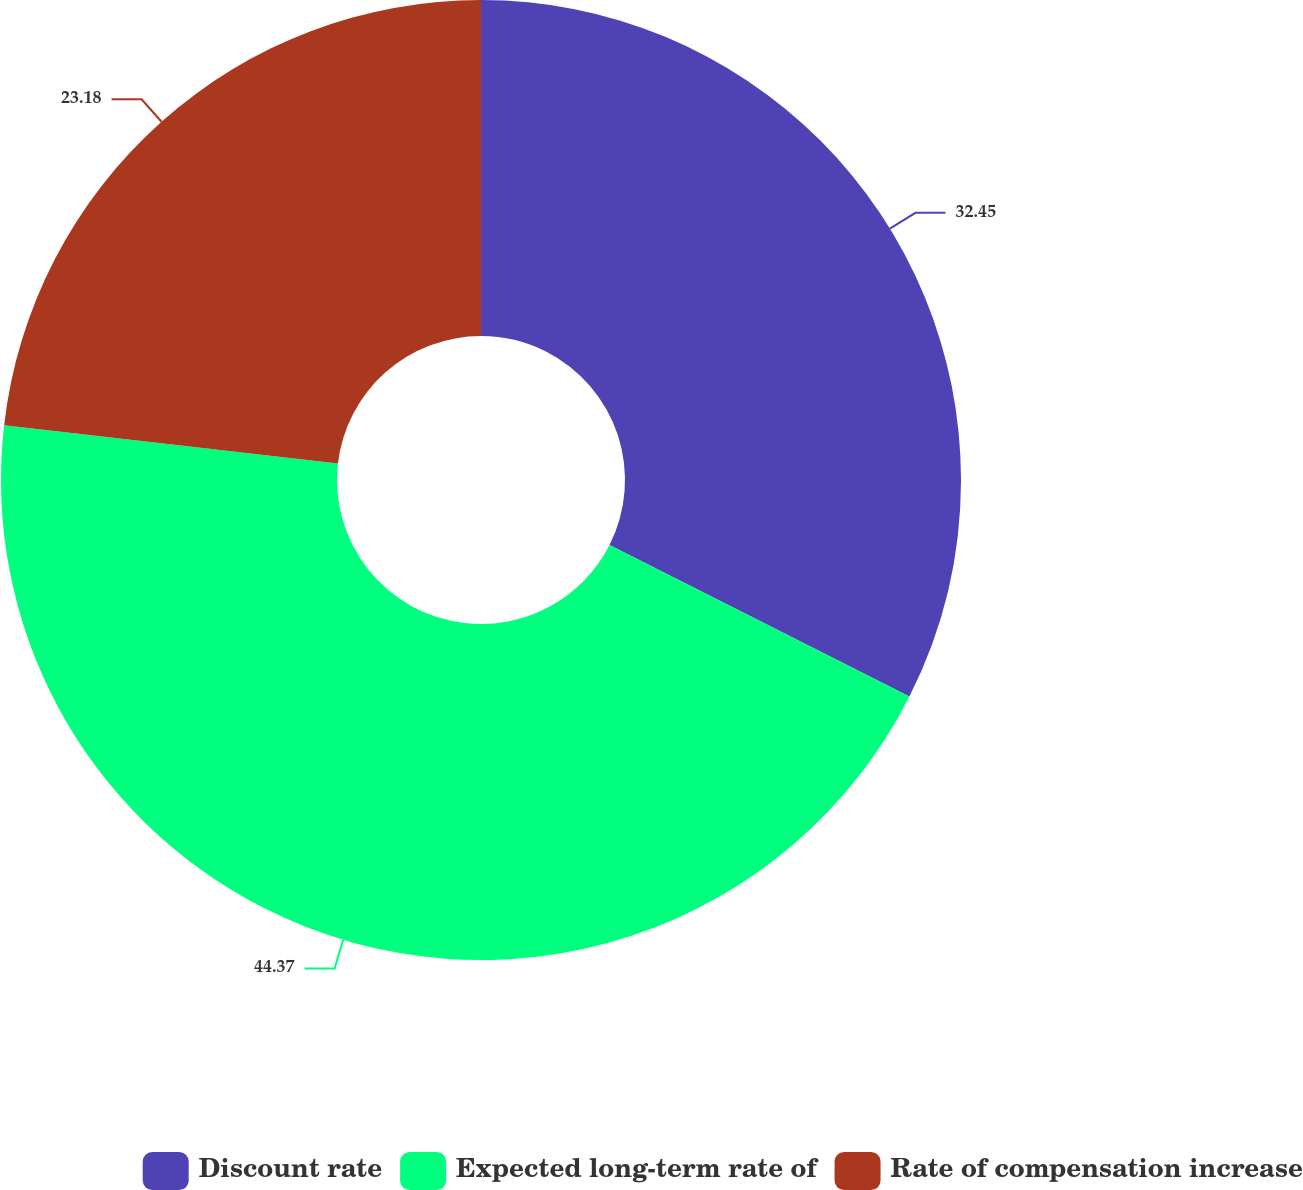<chart> <loc_0><loc_0><loc_500><loc_500><pie_chart><fcel>Discount rate<fcel>Expected long-term rate of<fcel>Rate of compensation increase<nl><fcel>32.45%<fcel>44.37%<fcel>23.18%<nl></chart> 